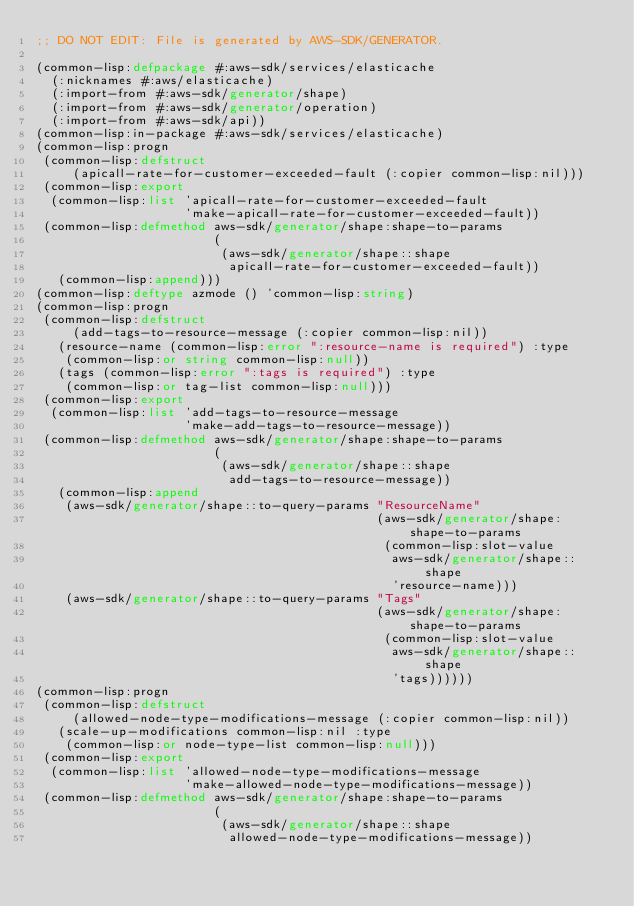Convert code to text. <code><loc_0><loc_0><loc_500><loc_500><_Lisp_>;; DO NOT EDIT: File is generated by AWS-SDK/GENERATOR.

(common-lisp:defpackage #:aws-sdk/services/elasticache
  (:nicknames #:aws/elasticache)
  (:import-from #:aws-sdk/generator/shape)
  (:import-from #:aws-sdk/generator/operation)
  (:import-from #:aws-sdk/api))
(common-lisp:in-package #:aws-sdk/services/elasticache)
(common-lisp:progn
 (common-lisp:defstruct
     (apicall-rate-for-customer-exceeded-fault (:copier common-lisp:nil)))
 (common-lisp:export
  (common-lisp:list 'apicall-rate-for-customer-exceeded-fault
                    'make-apicall-rate-for-customer-exceeded-fault))
 (common-lisp:defmethod aws-sdk/generator/shape:shape-to-params
                        (
                         (aws-sdk/generator/shape::shape
                          apicall-rate-for-customer-exceeded-fault))
   (common-lisp:append)))
(common-lisp:deftype azmode () 'common-lisp:string)
(common-lisp:progn
 (common-lisp:defstruct
     (add-tags-to-resource-message (:copier common-lisp:nil))
   (resource-name (common-lisp:error ":resource-name is required") :type
    (common-lisp:or string common-lisp:null))
   (tags (common-lisp:error ":tags is required") :type
    (common-lisp:or tag-list common-lisp:null)))
 (common-lisp:export
  (common-lisp:list 'add-tags-to-resource-message
                    'make-add-tags-to-resource-message))
 (common-lisp:defmethod aws-sdk/generator/shape:shape-to-params
                        (
                         (aws-sdk/generator/shape::shape
                          add-tags-to-resource-message))
   (common-lisp:append
    (aws-sdk/generator/shape::to-query-params "ResourceName"
                                              (aws-sdk/generator/shape:shape-to-params
                                               (common-lisp:slot-value
                                                aws-sdk/generator/shape::shape
                                                'resource-name)))
    (aws-sdk/generator/shape::to-query-params "Tags"
                                              (aws-sdk/generator/shape:shape-to-params
                                               (common-lisp:slot-value
                                                aws-sdk/generator/shape::shape
                                                'tags))))))
(common-lisp:progn
 (common-lisp:defstruct
     (allowed-node-type-modifications-message (:copier common-lisp:nil))
   (scale-up-modifications common-lisp:nil :type
    (common-lisp:or node-type-list common-lisp:null)))
 (common-lisp:export
  (common-lisp:list 'allowed-node-type-modifications-message
                    'make-allowed-node-type-modifications-message))
 (common-lisp:defmethod aws-sdk/generator/shape:shape-to-params
                        (
                         (aws-sdk/generator/shape::shape
                          allowed-node-type-modifications-message))</code> 